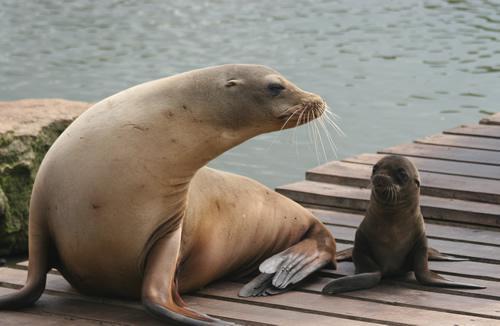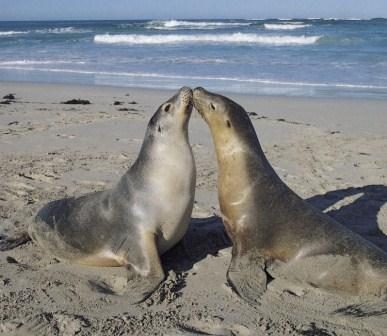The first image is the image on the left, the second image is the image on the right. Evaluate the accuracy of this statement regarding the images: "The right image contains exactly two seals.". Is it true? Answer yes or no. Yes. The first image is the image on the left, the second image is the image on the right. Given the left and right images, does the statement "The left and right image contains the same number of sea lions." hold true? Answer yes or no. Yes. 